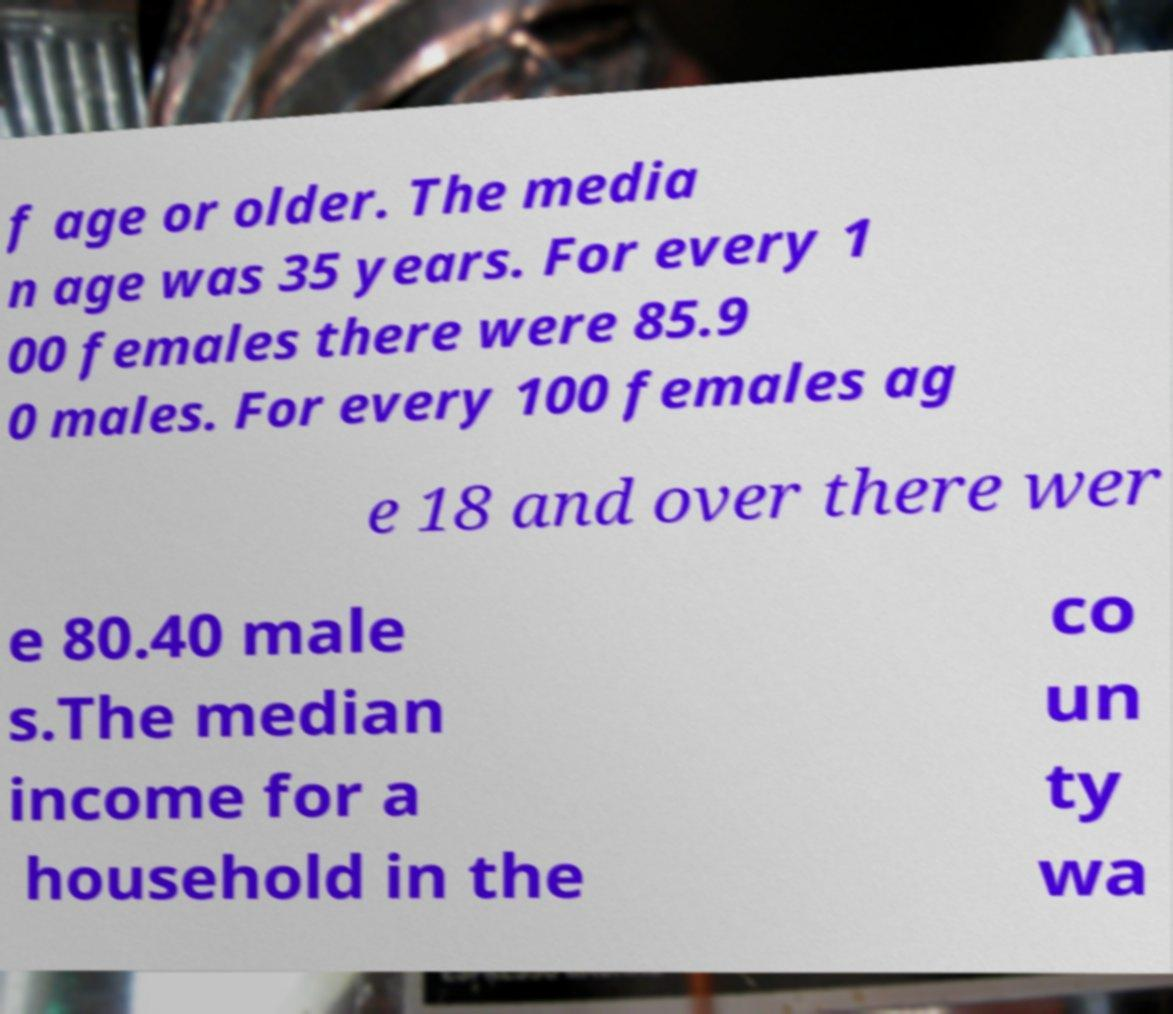For documentation purposes, I need the text within this image transcribed. Could you provide that? f age or older. The media n age was 35 years. For every 1 00 females there were 85.9 0 males. For every 100 females ag e 18 and over there wer e 80.40 male s.The median income for a household in the co un ty wa 